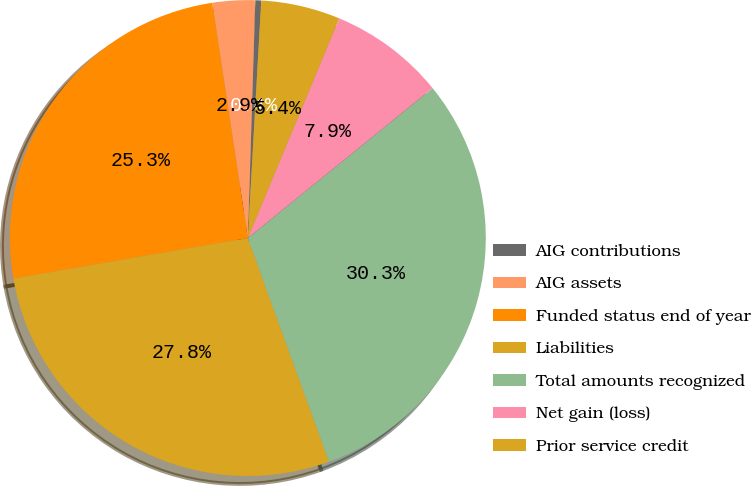Convert chart to OTSL. <chart><loc_0><loc_0><loc_500><loc_500><pie_chart><fcel>AIG contributions<fcel>AIG assets<fcel>Funded status end of year<fcel>Liabilities<fcel>Total amounts recognized<fcel>Net gain (loss)<fcel>Prior service credit<nl><fcel>0.4%<fcel>2.89%<fcel>25.33%<fcel>27.82%<fcel>30.31%<fcel>7.87%<fcel>5.38%<nl></chart> 